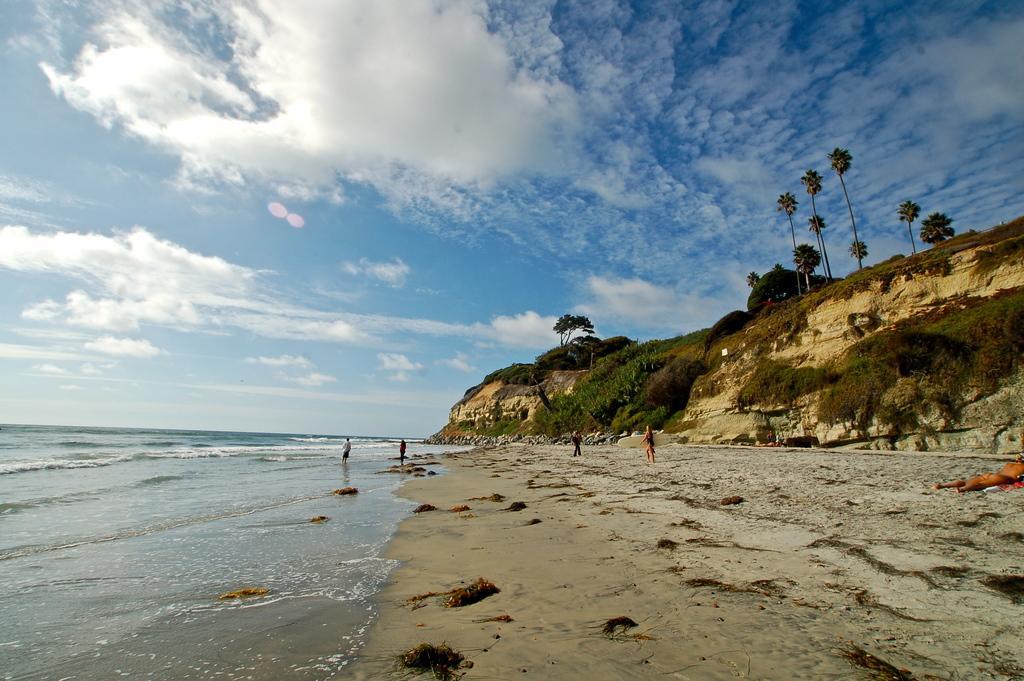In one or two sentences, can you explain what this image depicts? In this image we can see a group of people on the seashore. We can also see large water body, a group of trees and some plants on the hill and the sky which looks cloudy. 